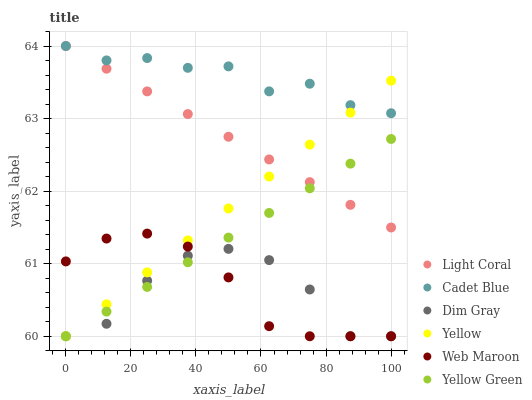Does Dim Gray have the minimum area under the curve?
Answer yes or no. Yes. Does Cadet Blue have the maximum area under the curve?
Answer yes or no. Yes. Does Yellow Green have the minimum area under the curve?
Answer yes or no. No. Does Yellow Green have the maximum area under the curve?
Answer yes or no. No. Is Yellow the smoothest?
Answer yes or no. Yes. Is Dim Gray the roughest?
Answer yes or no. Yes. Is Yellow Green the smoothest?
Answer yes or no. No. Is Yellow Green the roughest?
Answer yes or no. No. Does Dim Gray have the lowest value?
Answer yes or no. Yes. Does Light Coral have the lowest value?
Answer yes or no. No. Does Cadet Blue have the highest value?
Answer yes or no. Yes. Does Yellow Green have the highest value?
Answer yes or no. No. Is Dim Gray less than Cadet Blue?
Answer yes or no. Yes. Is Cadet Blue greater than Dim Gray?
Answer yes or no. Yes. Does Light Coral intersect Cadet Blue?
Answer yes or no. Yes. Is Light Coral less than Cadet Blue?
Answer yes or no. No. Is Light Coral greater than Cadet Blue?
Answer yes or no. No. Does Dim Gray intersect Cadet Blue?
Answer yes or no. No. 